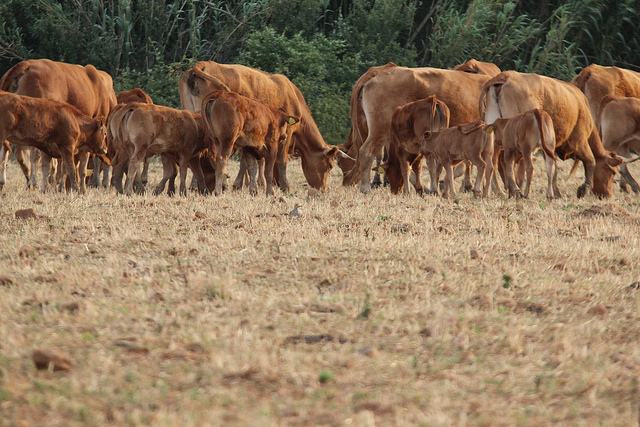Can you elaborate on the elements of the picture provided? The image depicts a tranquil rural scene with multiple cows scattered across a dried field. On the leftmost side, there is a group of cows, one of which slightly overlaps the edge of the frame. As we move towards the center, we observe several other cows spaced at varying distances—some are nearer, while others are farther from the viewer. On the right side, there's a dense cluster of cows, with a few almost reaching the image's edge. All these cows appear to be grazing, their heads lowered towards the ground, indicating they are likely feeding or foraging. The background is enriched with some greenery and bushes, adding depth to the scene and providing a sense of place in a natural environment. 